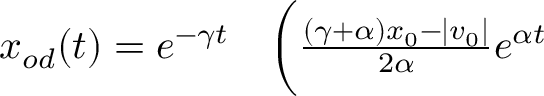Convert formula to latex. <formula><loc_0><loc_0><loc_500><loc_500>\begin{array} { r l } { x _ { o d } ( t ) = e ^ { - \gamma t } } & \Big ( \frac { ( \gamma + \alpha ) x _ { 0 } - | v _ { 0 } | } { 2 \alpha } e ^ { \alpha t } } \end{array}</formula> 